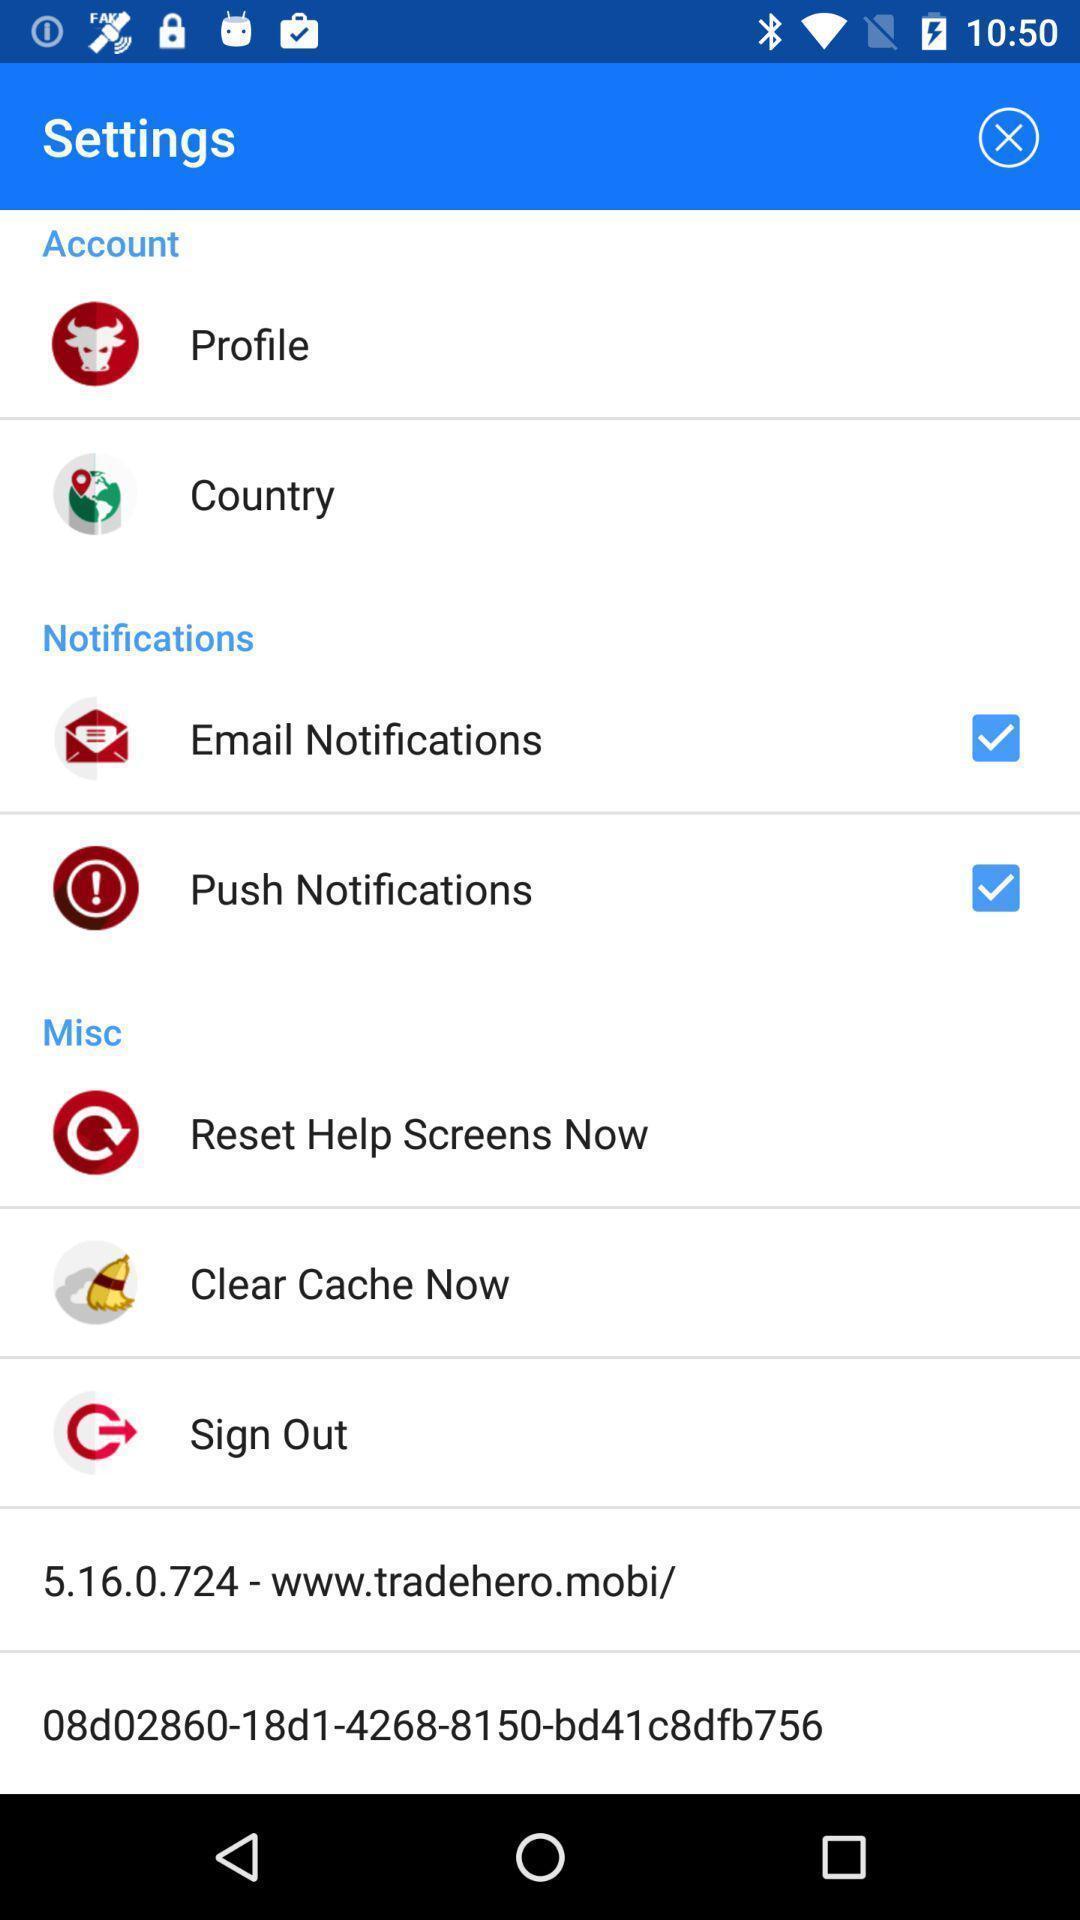Provide a textual representation of this image. Settings page displaying. 